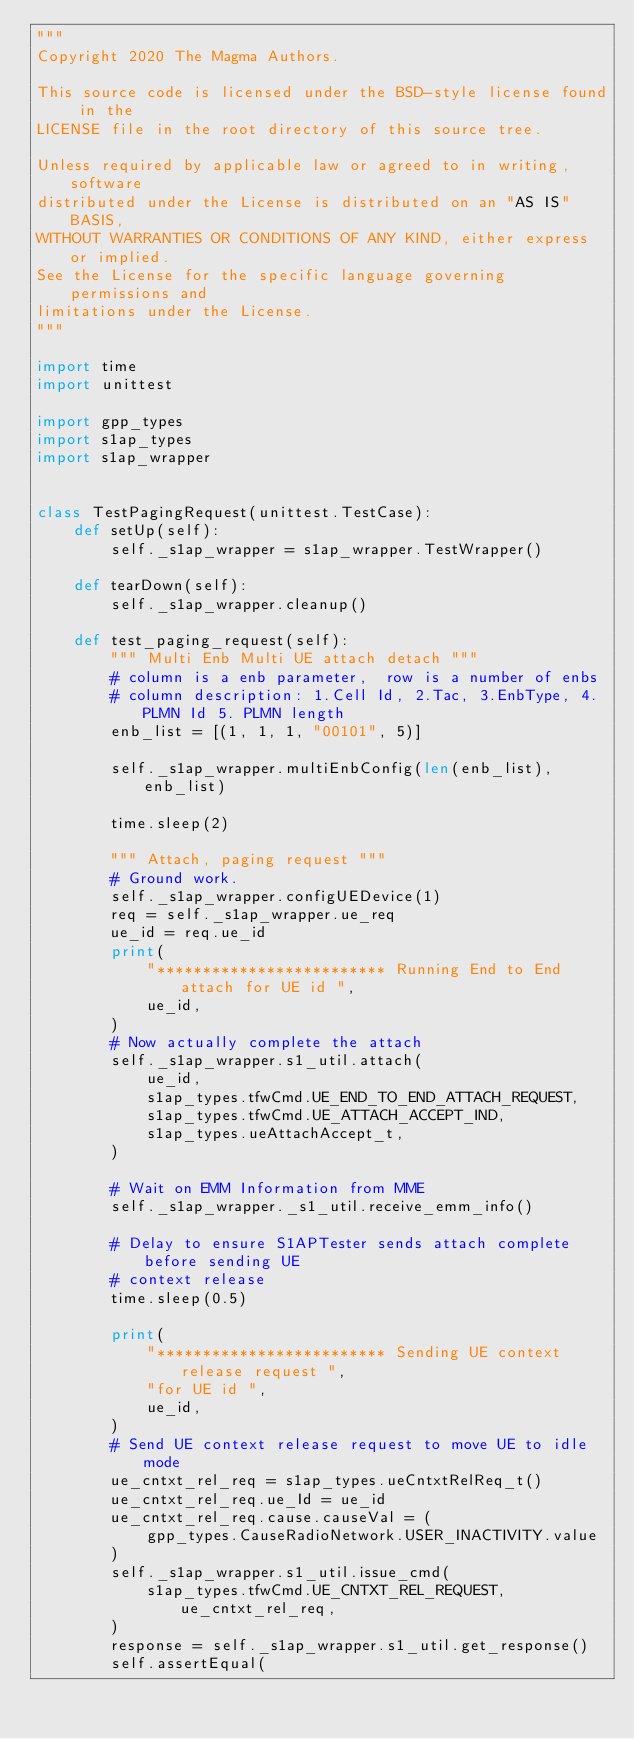Convert code to text. <code><loc_0><loc_0><loc_500><loc_500><_Python_>"""
Copyright 2020 The Magma Authors.

This source code is licensed under the BSD-style license found in the
LICENSE file in the root directory of this source tree.

Unless required by applicable law or agreed to in writing, software
distributed under the License is distributed on an "AS IS" BASIS,
WITHOUT WARRANTIES OR CONDITIONS OF ANY KIND, either express or implied.
See the License for the specific language governing permissions and
limitations under the License.
"""

import time
import unittest

import gpp_types
import s1ap_types
import s1ap_wrapper


class TestPagingRequest(unittest.TestCase):
    def setUp(self):
        self._s1ap_wrapper = s1ap_wrapper.TestWrapper()

    def tearDown(self):
        self._s1ap_wrapper.cleanup()

    def test_paging_request(self):
        """ Multi Enb Multi UE attach detach """
        # column is a enb parameter,  row is a number of enbs
        # column description: 1.Cell Id, 2.Tac, 3.EnbType, 4.PLMN Id 5. PLMN length
        enb_list = [(1, 1, 1, "00101", 5)]

        self._s1ap_wrapper.multiEnbConfig(len(enb_list), enb_list)

        time.sleep(2)

        """ Attach, paging request """
        # Ground work.
        self._s1ap_wrapper.configUEDevice(1)
        req = self._s1ap_wrapper.ue_req
        ue_id = req.ue_id
        print(
            "************************* Running End to End attach for UE id ",
            ue_id,
        )
        # Now actually complete the attach
        self._s1ap_wrapper.s1_util.attach(
            ue_id,
            s1ap_types.tfwCmd.UE_END_TO_END_ATTACH_REQUEST,
            s1ap_types.tfwCmd.UE_ATTACH_ACCEPT_IND,
            s1ap_types.ueAttachAccept_t,
        )

        # Wait on EMM Information from MME
        self._s1ap_wrapper._s1_util.receive_emm_info()

        # Delay to ensure S1APTester sends attach complete before sending UE
        # context release
        time.sleep(0.5)

        print(
            "************************* Sending UE context release request ",
            "for UE id ",
            ue_id,
        )
        # Send UE context release request to move UE to idle mode
        ue_cntxt_rel_req = s1ap_types.ueCntxtRelReq_t()
        ue_cntxt_rel_req.ue_Id = ue_id
        ue_cntxt_rel_req.cause.causeVal = (
            gpp_types.CauseRadioNetwork.USER_INACTIVITY.value
        )
        self._s1ap_wrapper.s1_util.issue_cmd(
            s1ap_types.tfwCmd.UE_CNTXT_REL_REQUEST, ue_cntxt_rel_req,
        )
        response = self._s1ap_wrapper.s1_util.get_response()
        self.assertEqual(</code> 